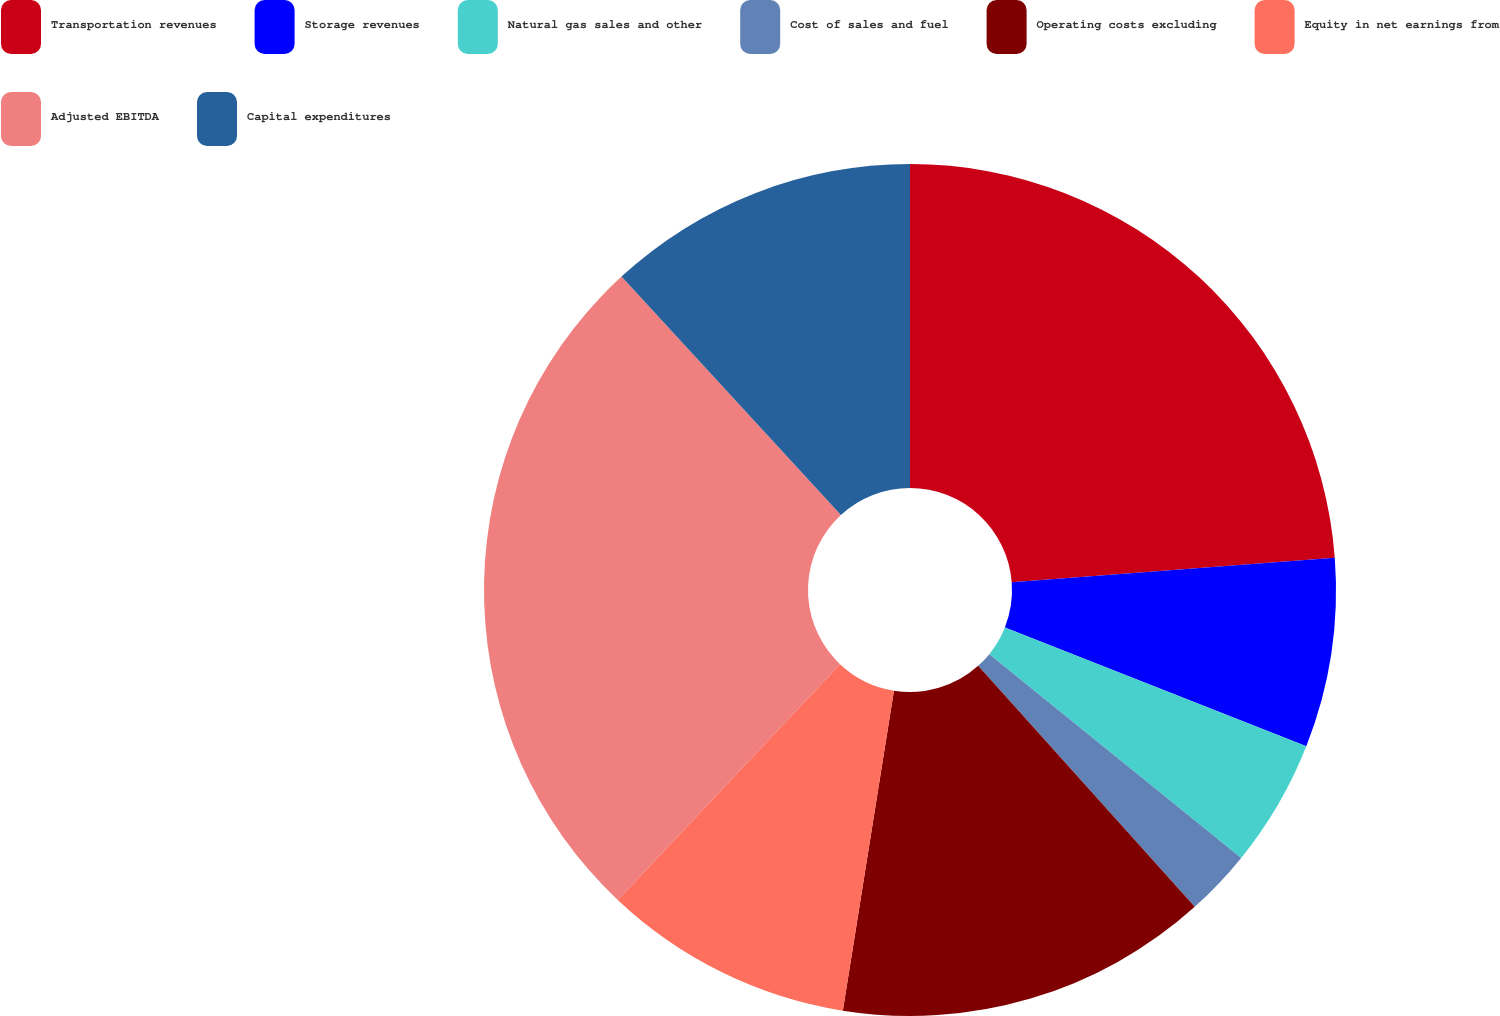Convert chart. <chart><loc_0><loc_0><loc_500><loc_500><pie_chart><fcel>Transportation revenues<fcel>Storage revenues<fcel>Natural gas sales and other<fcel>Cost of sales and fuel<fcel>Operating costs excluding<fcel>Equity in net earnings from<fcel>Adjusted EBITDA<fcel>Capital expenditures<nl><fcel>23.79%<fcel>7.18%<fcel>4.85%<fcel>2.52%<fcel>14.17%<fcel>9.51%<fcel>26.12%<fcel>11.84%<nl></chart> 